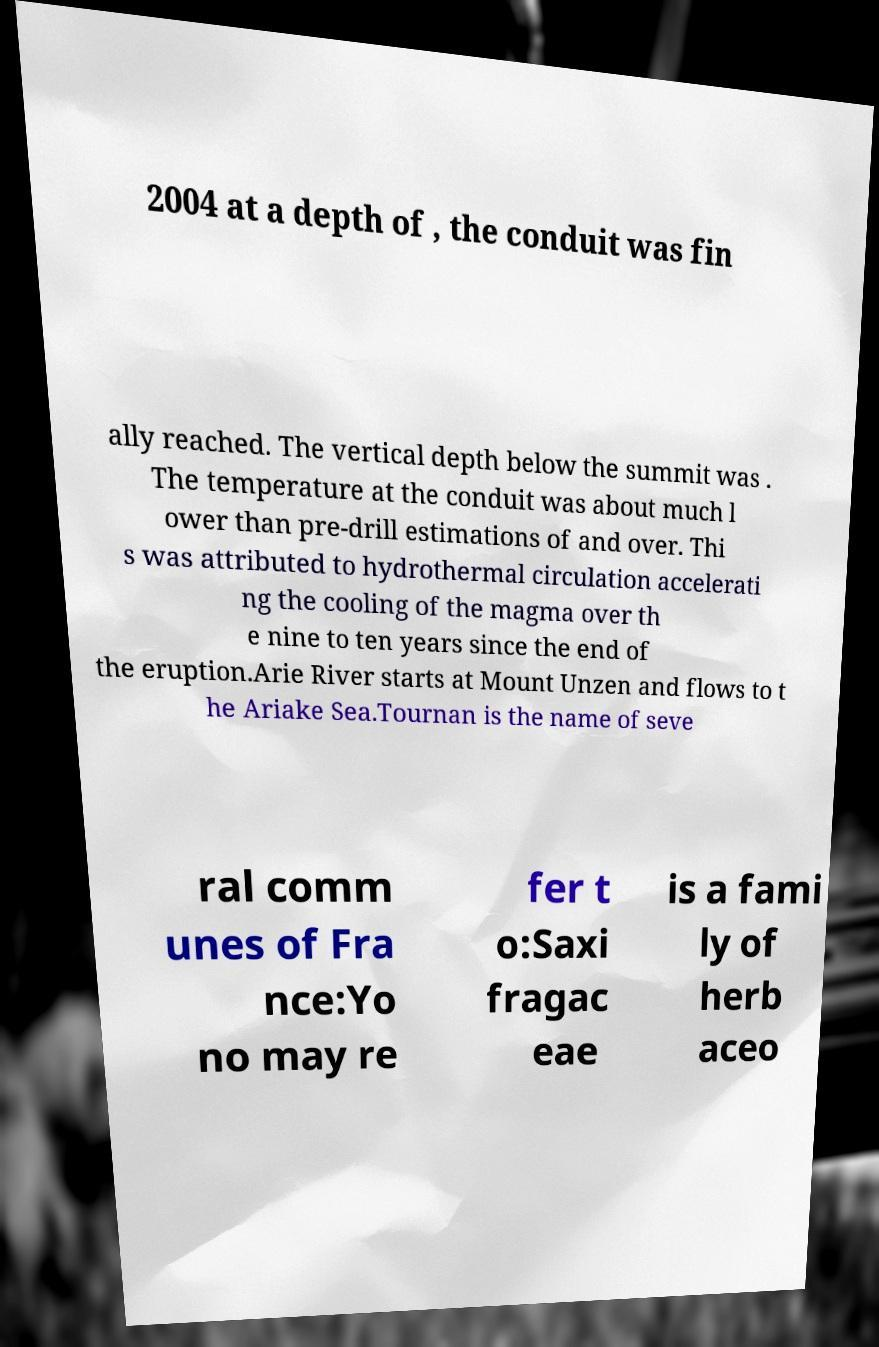Could you assist in decoding the text presented in this image and type it out clearly? 2004 at a depth of , the conduit was fin ally reached. The vertical depth below the summit was . The temperature at the conduit was about much l ower than pre-drill estimations of and over. Thi s was attributed to hydrothermal circulation accelerati ng the cooling of the magma over th e nine to ten years since the end of the eruption.Arie River starts at Mount Unzen and flows to t he Ariake Sea.Tournan is the name of seve ral comm unes of Fra nce:Yo no may re fer t o:Saxi fragac eae is a fami ly of herb aceo 